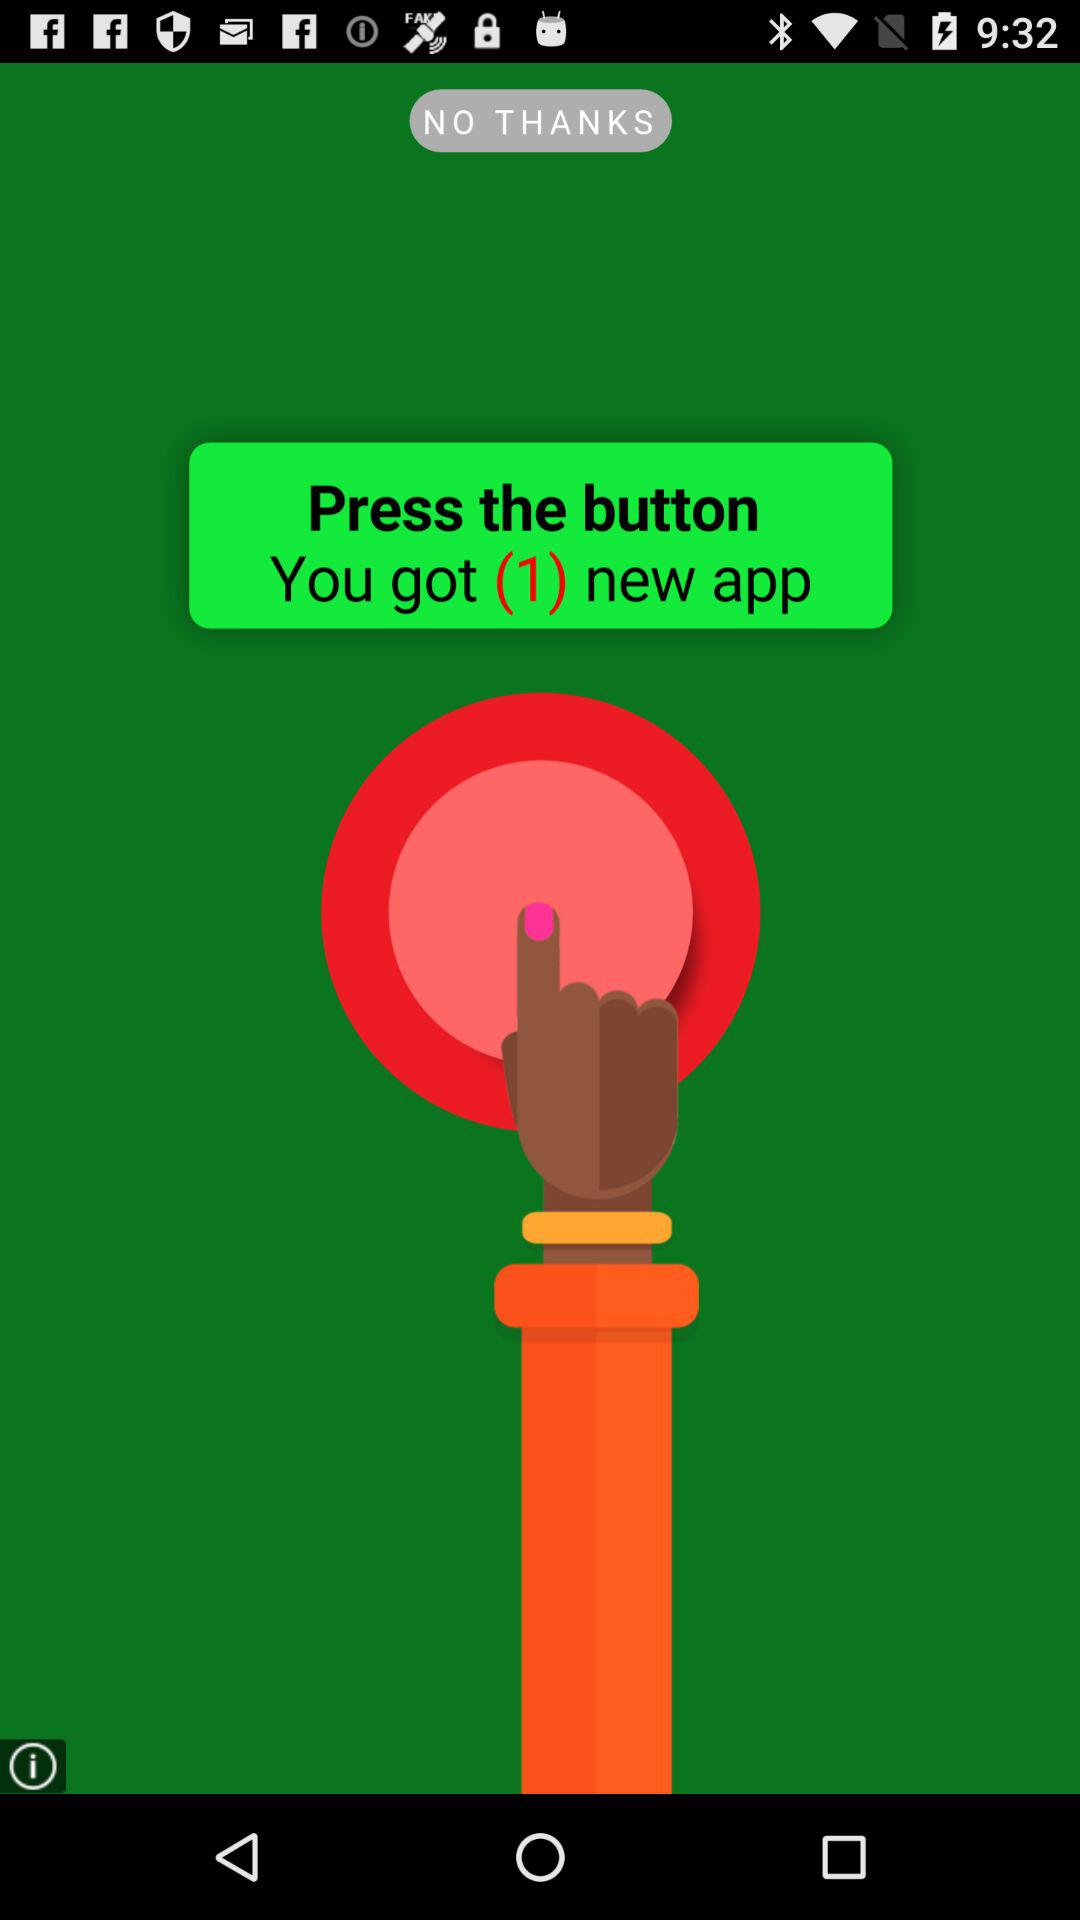How many new app notifications are on the screen? There is 1 new app notification. 